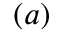<formula> <loc_0><loc_0><loc_500><loc_500>( a )</formula> 